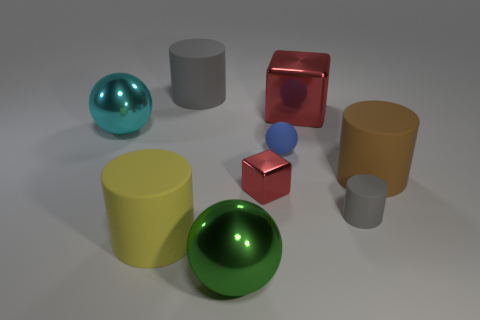Is the small metal cube the same color as the tiny sphere?
Make the answer very short. No. There is a shiny ball that is on the left side of the gray thing left of the tiny shiny block; how many shiny objects are to the left of it?
Ensure brevity in your answer.  0. The green thing is what size?
Ensure brevity in your answer.  Large. There is a cyan ball that is the same size as the green ball; what is it made of?
Keep it short and to the point. Metal. There is a yellow matte object; how many cylinders are on the right side of it?
Ensure brevity in your answer.  3. Is the sphere that is to the left of the big yellow object made of the same material as the big sphere in front of the small gray thing?
Make the answer very short. Yes. There is a metal thing that is left of the large matte thing behind the big shiny object to the right of the green object; what is its shape?
Offer a very short reply. Sphere. What shape is the yellow thing?
Keep it short and to the point. Cylinder. There is a gray rubber object that is the same size as the green metallic ball; what is its shape?
Give a very brief answer. Cylinder. What number of other things are the same color as the small cylinder?
Ensure brevity in your answer.  1. 